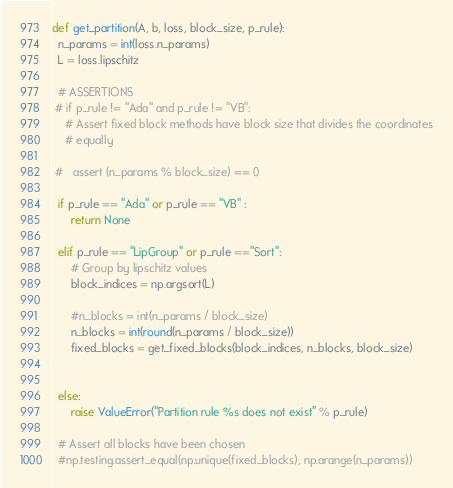<code> <loc_0><loc_0><loc_500><loc_500><_Python_>def get_partition(A, b, loss, block_size, p_rule):
  n_params = int(loss.n_params)
  L = loss.lipschitz

  # ASSERTIONS
 # if p_rule != "Ada" and p_rule != "VB":
    # Assert fixed block methods have block size that divides the coordinates
    # equally
    
 #   assert (n_params % block_size) == 0 

  if p_rule == "Ada" or p_rule == "VB" :
      return None
      
  elif p_rule == "LipGroup" or p_rule =="Sort":
      # Group by lipschitz values
      block_indices = np.argsort(L)
      
      #n_blocks = int(n_params / block_size)
      n_blocks = int(round(n_params / block_size))
      fixed_blocks = get_fixed_blocks(block_indices, n_blocks, block_size)


  else:
      raise ValueError("Partition rule %s does not exist" % p_rule)

  # Assert all blocks have been chosen
  #np.testing.assert_equal(np.unique(fixed_blocks), np.arange(n_params)) 
</code> 